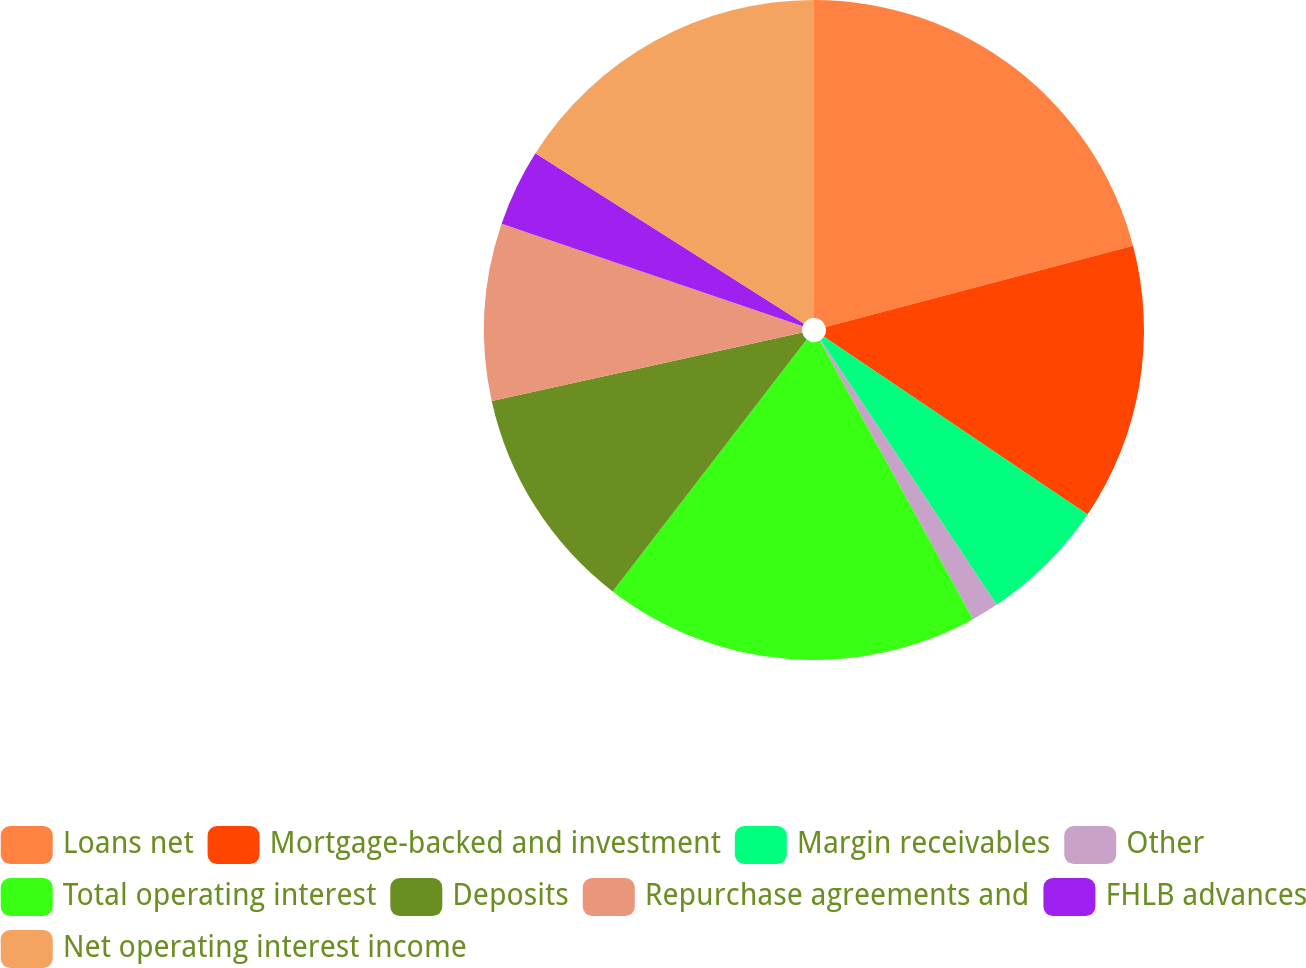Convert chart. <chart><loc_0><loc_0><loc_500><loc_500><pie_chart><fcel>Loans net<fcel>Mortgage-backed and investment<fcel>Margin receivables<fcel>Other<fcel>Total operating interest<fcel>Deposits<fcel>Repurchase agreements and<fcel>FHLB advances<fcel>Net operating interest income<nl><fcel>20.89%<fcel>13.56%<fcel>6.22%<fcel>1.33%<fcel>18.45%<fcel>11.11%<fcel>8.67%<fcel>3.78%<fcel>16.0%<nl></chart> 